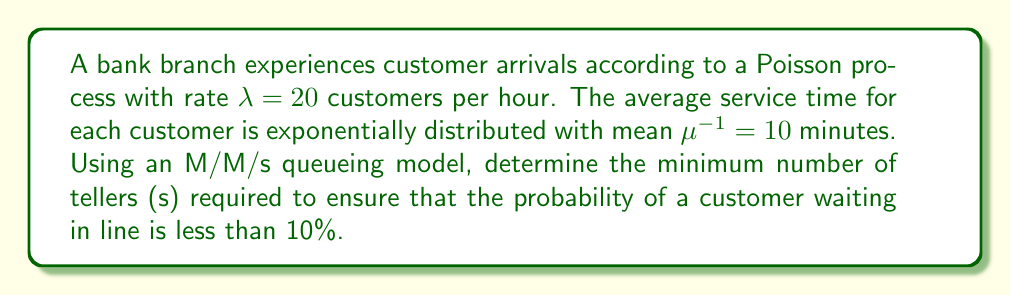What is the answer to this math problem? To solve this problem, we'll use the M/M/s queueing model and follow these steps:

1. Convert units:
   $\lambda = 20$ customers/hour
   $\mu = 6$ customers/hour (since $\mu^{-1} = 10$ minutes = 1/6 hour)

2. Calculate the traffic intensity $\rho = \frac{\lambda}{s\mu}$

3. Use the Erlang C formula to calculate the probability of waiting:

   $$P_w = \frac{(s\rho)^s}{s!(1-\rho)} \cdot \left[\sum_{n=0}^{s-1}\frac{(s\rho)^n}{n!} + \frac{(s\rho)^s}{s!(1-\rho)}\right]^{-1}$$

4. Iterate through values of s until $P_w < 0.1$

Let's start with $s = 3$:

$\rho = \frac{20}{3 \cdot 6} \approx 1.11$

Since $\rho > 1$, the system is unstable. We need at least 4 tellers.

For $s = 4$:

$\rho = \frac{20}{4 \cdot 6} = 0.833$

$$P_w = \frac{(4 \cdot 0.833)^4}{4!(1-0.833)} \cdot \left[\sum_{n=0}^{3}\frac{(4 \cdot 0.833)^n}{n!} + \frac{(4 \cdot 0.833)^4}{4!(1-0.833)}\right]^{-1} \approx 0.7425$$

This is still greater than 0.1, so we need more tellers.

For $s = 5$:

$\rho = \frac{20}{5 \cdot 6} = 0.667$

$$P_w = \frac{(5 \cdot 0.667)^5}{5!(1-0.667)} \cdot \left[\sum_{n=0}^{4}\frac{(5 \cdot 0.667)^n}{n!} + \frac{(5 \cdot 0.667)^5}{5!(1-0.667)}\right]^{-1} \approx 0.2815$$

Still greater than 0.1.

For $s = 6$:

$\rho = \frac{20}{6 \cdot 6} = 0.556$

$$P_w = \frac{(6 \cdot 0.556)^6}{6!(1-0.556)} \cdot \left[\sum_{n=0}^{5}\frac{(6 \cdot 0.556)^n}{n!} + \frac{(6 \cdot 0.556)^6}{6!(1-0.556)}\right]^{-1} \approx 0.0815$$

This is less than 0.1, so 6 tellers are sufficient.
Answer: 6 tellers 